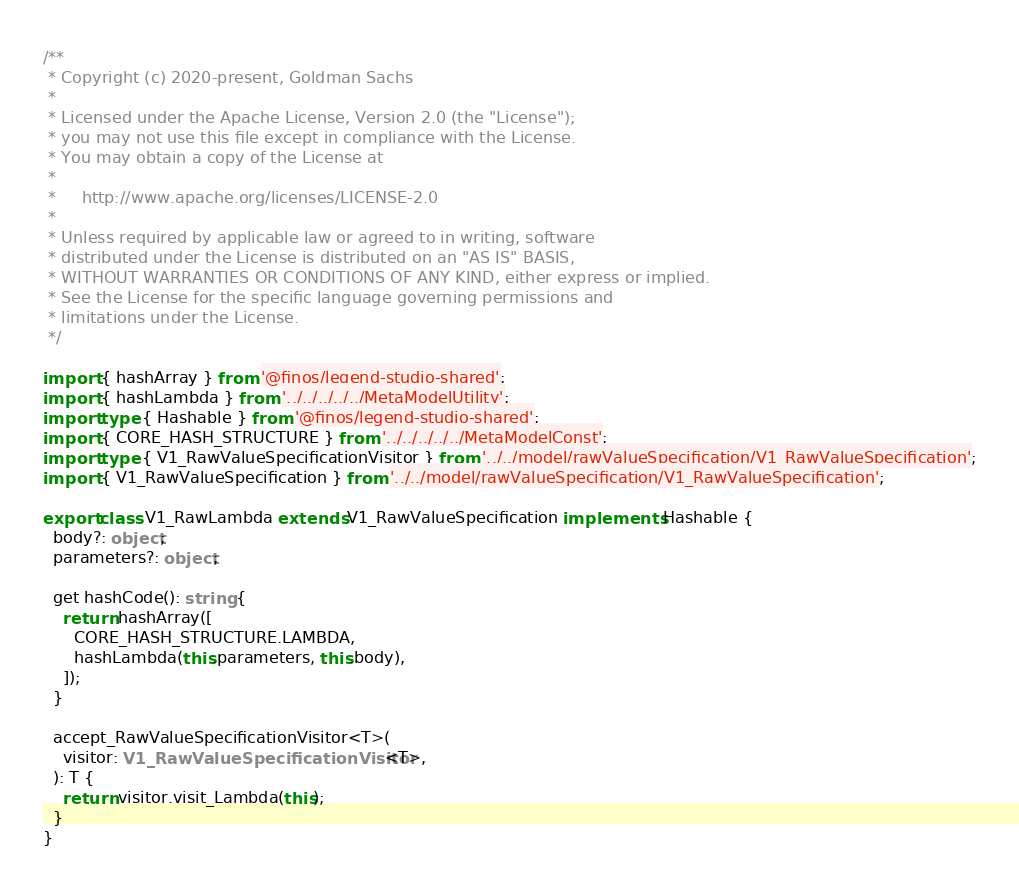<code> <loc_0><loc_0><loc_500><loc_500><_TypeScript_>/**
 * Copyright (c) 2020-present, Goldman Sachs
 *
 * Licensed under the Apache License, Version 2.0 (the "License");
 * you may not use this file except in compliance with the License.
 * You may obtain a copy of the License at
 *
 *     http://www.apache.org/licenses/LICENSE-2.0
 *
 * Unless required by applicable law or agreed to in writing, software
 * distributed under the License is distributed on an "AS IS" BASIS,
 * WITHOUT WARRANTIES OR CONDITIONS OF ANY KIND, either express or implied.
 * See the License for the specific language governing permissions and
 * limitations under the License.
 */

import { hashArray } from '@finos/legend-studio-shared';
import { hashLambda } from '../../../../../MetaModelUtility';
import type { Hashable } from '@finos/legend-studio-shared';
import { CORE_HASH_STRUCTURE } from '../../../../../MetaModelConst';
import type { V1_RawValueSpecificationVisitor } from '../../model/rawValueSpecification/V1_RawValueSpecification';
import { V1_RawValueSpecification } from '../../model/rawValueSpecification/V1_RawValueSpecification';

export class V1_RawLambda extends V1_RawValueSpecification implements Hashable {
  body?: object;
  parameters?: object;

  get hashCode(): string {
    return hashArray([
      CORE_HASH_STRUCTURE.LAMBDA,
      hashLambda(this.parameters, this.body),
    ]);
  }

  accept_RawValueSpecificationVisitor<T>(
    visitor: V1_RawValueSpecificationVisitor<T>,
  ): T {
    return visitor.visit_Lambda(this);
  }
}
</code> 